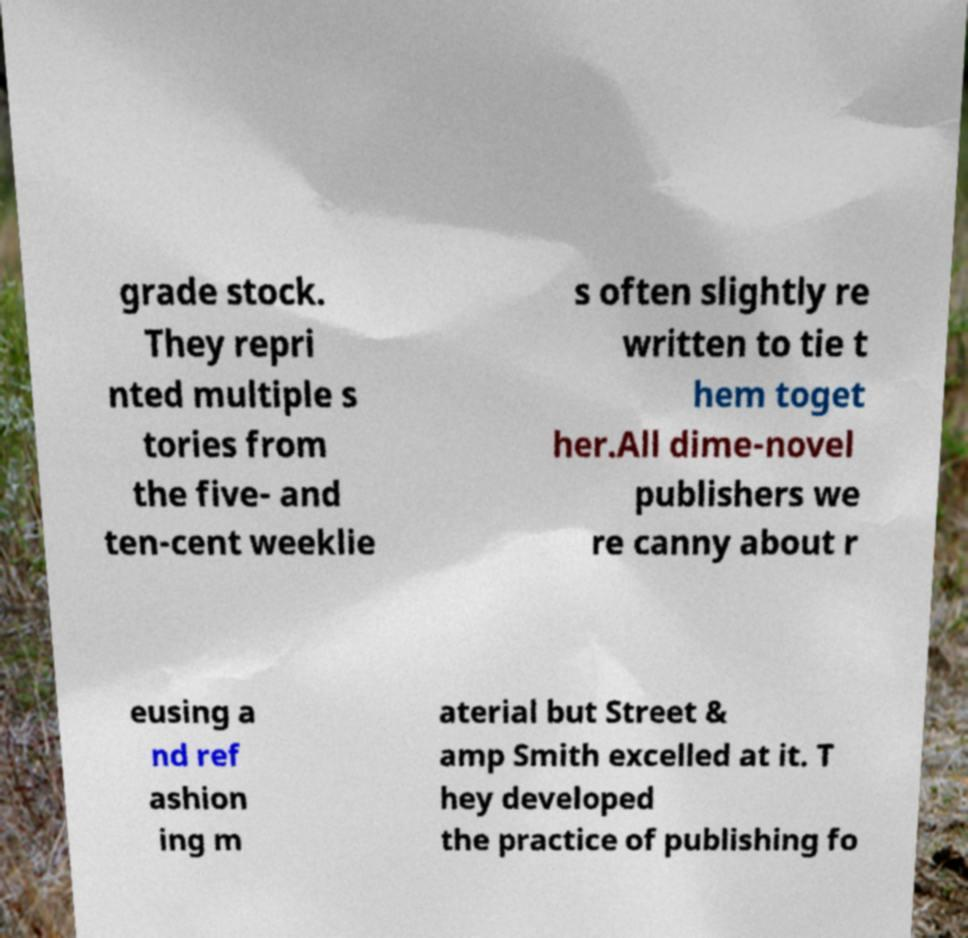Could you extract and type out the text from this image? grade stock. They repri nted multiple s tories from the five- and ten-cent weeklie s often slightly re written to tie t hem toget her.All dime-novel publishers we re canny about r eusing a nd ref ashion ing m aterial but Street & amp Smith excelled at it. T hey developed the practice of publishing fo 